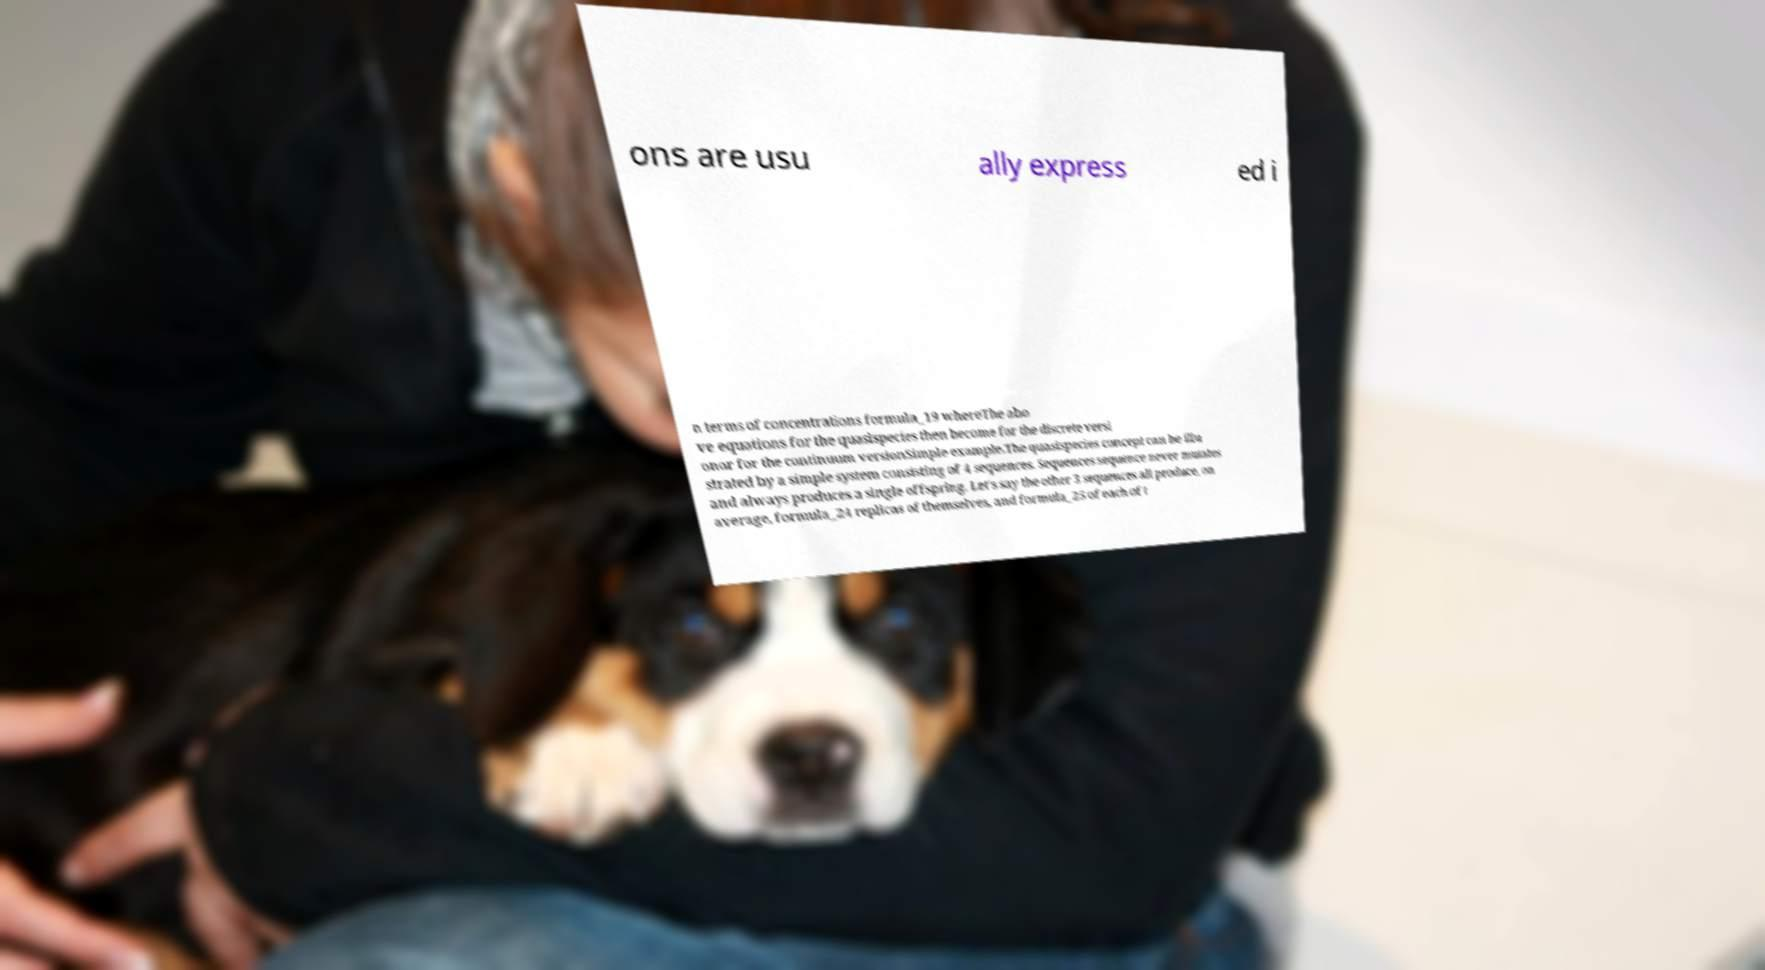Could you extract and type out the text from this image? ons are usu ally express ed i n terms of concentrations formula_19 whereThe abo ve equations for the quasispecies then become for the discrete versi onor for the continuum versionSimple example.The quasispecies concept can be illu strated by a simple system consisting of 4 sequences. Sequences sequence never mutates and always produces a single offspring. Let's say the other 3 sequences all produce, on average, formula_24 replicas of themselves, and formula_25 of each of t 